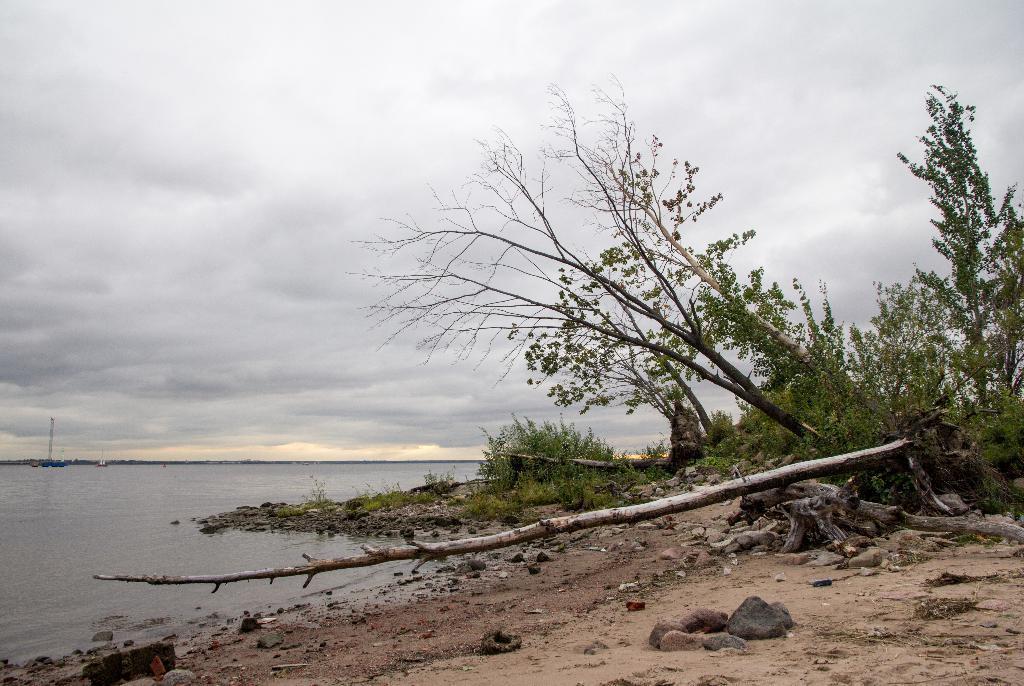In one or two sentences, can you explain what this image depicts? In this image there is one lake and on the right side there are some trees, rocks, sand and some plants. At the top of the image there is sky. 